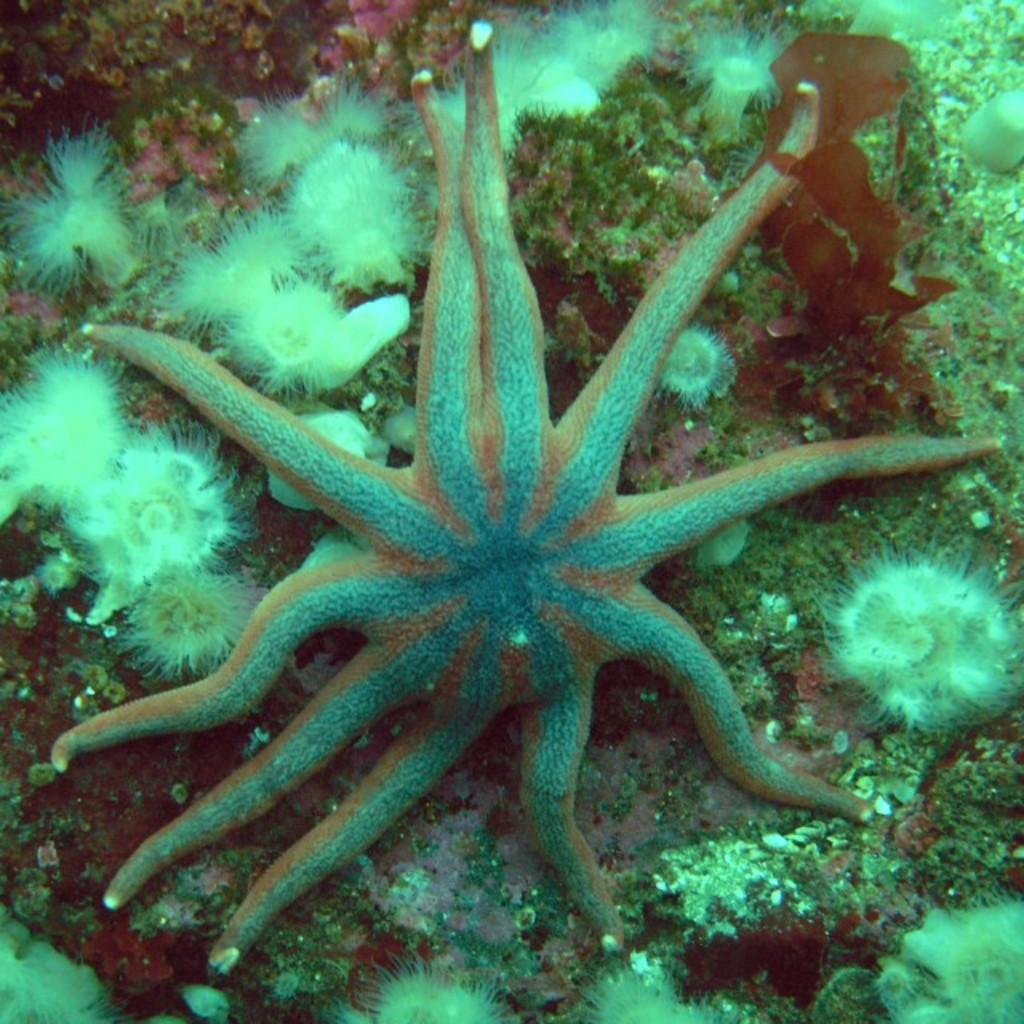What type of animal can be seen in the image? There is a water animal in the image. Can you describe the environment in which the animal is located? The water animal is in a water marine, which suggests it is in an aquatic environment. What type of gate can be seen in the image? There is no gate present in the image; it features a water animal in a water marine. Can you describe the guide who is leading the water animal in the image? There is no guide present in the image; it only features a water animal in a water marine. 